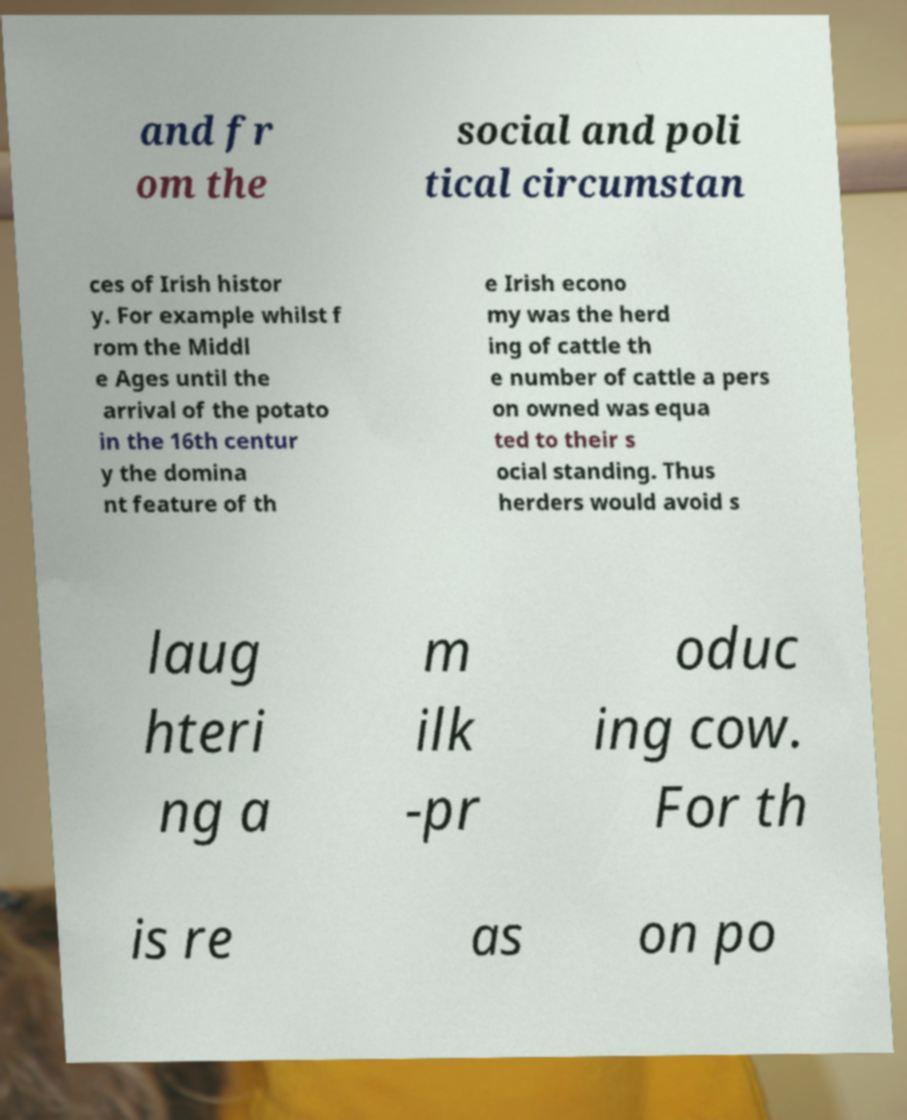There's text embedded in this image that I need extracted. Can you transcribe it verbatim? and fr om the social and poli tical circumstan ces of Irish histor y. For example whilst f rom the Middl e Ages until the arrival of the potato in the 16th centur y the domina nt feature of th e Irish econo my was the herd ing of cattle th e number of cattle a pers on owned was equa ted to their s ocial standing. Thus herders would avoid s laug hteri ng a m ilk -pr oduc ing cow. For th is re as on po 